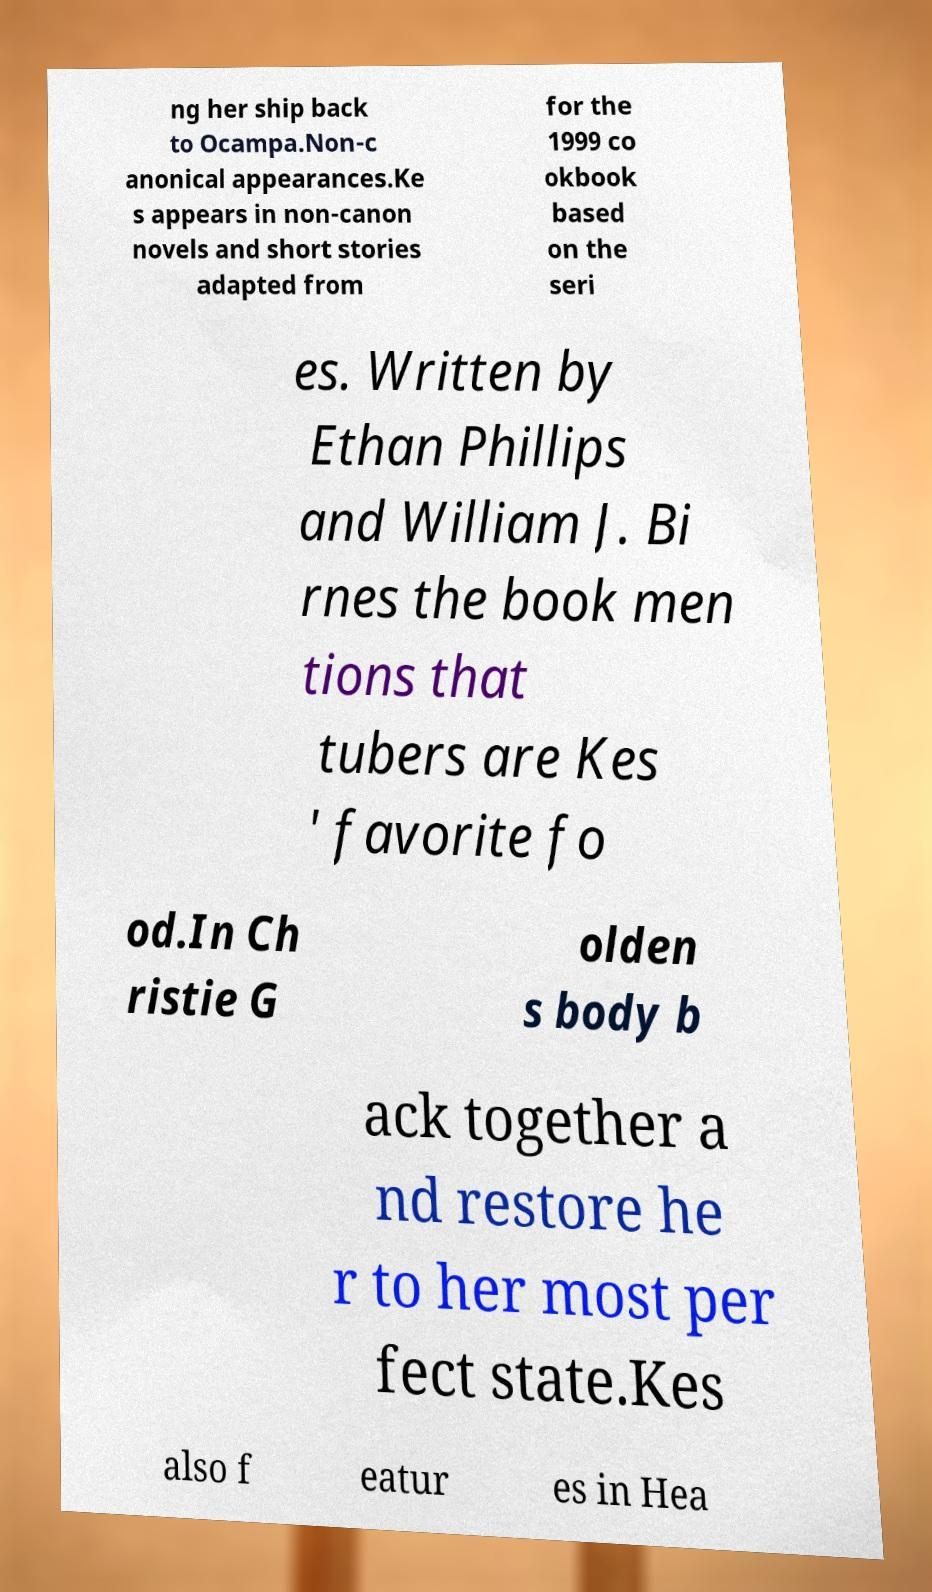Could you assist in decoding the text presented in this image and type it out clearly? ng her ship back to Ocampa.Non-c anonical appearances.Ke s appears in non-canon novels and short stories adapted from for the 1999 co okbook based on the seri es. Written by Ethan Phillips and William J. Bi rnes the book men tions that tubers are Kes ' favorite fo od.In Ch ristie G olden s body b ack together a nd restore he r to her most per fect state.Kes also f eatur es in Hea 